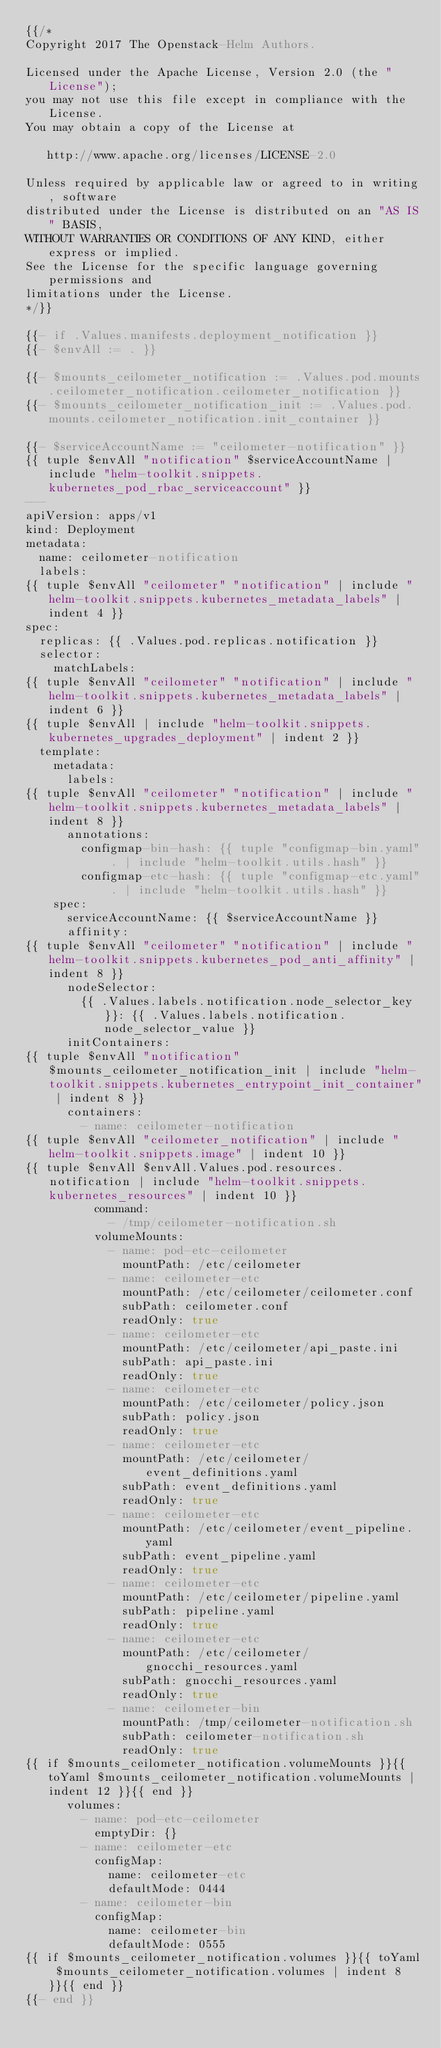<code> <loc_0><loc_0><loc_500><loc_500><_YAML_>{{/*
Copyright 2017 The Openstack-Helm Authors.

Licensed under the Apache License, Version 2.0 (the "License");
you may not use this file except in compliance with the License.
You may obtain a copy of the License at

   http://www.apache.org/licenses/LICENSE-2.0

Unless required by applicable law or agreed to in writing, software
distributed under the License is distributed on an "AS IS" BASIS,
WITHOUT WARRANTIES OR CONDITIONS OF ANY KIND, either express or implied.
See the License for the specific language governing permissions and
limitations under the License.
*/}}

{{- if .Values.manifests.deployment_notification }}
{{- $envAll := . }}

{{- $mounts_ceilometer_notification := .Values.pod.mounts.ceilometer_notification.ceilometer_notification }}
{{- $mounts_ceilometer_notification_init := .Values.pod.mounts.ceilometer_notification.init_container }}

{{- $serviceAccountName := "ceilometer-notification" }}
{{ tuple $envAll "notification" $serviceAccountName | include "helm-toolkit.snippets.kubernetes_pod_rbac_serviceaccount" }}
---
apiVersion: apps/v1
kind: Deployment
metadata:
  name: ceilometer-notification
  labels:
{{ tuple $envAll "ceilometer" "notification" | include "helm-toolkit.snippets.kubernetes_metadata_labels" | indent 4 }}
spec:
  replicas: {{ .Values.pod.replicas.notification }}
  selector:
    matchLabels:
{{ tuple $envAll "ceilometer" "notification" | include "helm-toolkit.snippets.kubernetes_metadata_labels" | indent 6 }}
{{ tuple $envAll | include "helm-toolkit.snippets.kubernetes_upgrades_deployment" | indent 2 }}
  template:
    metadata:
      labels:
{{ tuple $envAll "ceilometer" "notification" | include "helm-toolkit.snippets.kubernetes_metadata_labels" | indent 8 }}
      annotations:
        configmap-bin-hash: {{ tuple "configmap-bin.yaml" . | include "helm-toolkit.utils.hash" }}
        configmap-etc-hash: {{ tuple "configmap-etc.yaml" . | include "helm-toolkit.utils.hash" }}
    spec:
      serviceAccountName: {{ $serviceAccountName }}
      affinity:
{{ tuple $envAll "ceilometer" "notification" | include "helm-toolkit.snippets.kubernetes_pod_anti_affinity" | indent 8 }}
      nodeSelector:
        {{ .Values.labels.notification.node_selector_key }}: {{ .Values.labels.notification.node_selector_value }}
      initContainers:
{{ tuple $envAll "notification" $mounts_ceilometer_notification_init | include "helm-toolkit.snippets.kubernetes_entrypoint_init_container" | indent 8 }}
      containers:
        - name: ceilometer-notification
{{ tuple $envAll "ceilometer_notification" | include "helm-toolkit.snippets.image" | indent 10 }}
{{ tuple $envAll $envAll.Values.pod.resources.notification | include "helm-toolkit.snippets.kubernetes_resources" | indent 10 }}
          command:
            - /tmp/ceilometer-notification.sh
          volumeMounts:
            - name: pod-etc-ceilometer
              mountPath: /etc/ceilometer
            - name: ceilometer-etc
              mountPath: /etc/ceilometer/ceilometer.conf
              subPath: ceilometer.conf
              readOnly: true
            - name: ceilometer-etc
              mountPath: /etc/ceilometer/api_paste.ini
              subPath: api_paste.ini
              readOnly: true
            - name: ceilometer-etc
              mountPath: /etc/ceilometer/policy.json
              subPath: policy.json
              readOnly: true
            - name: ceilometer-etc
              mountPath: /etc/ceilometer/event_definitions.yaml
              subPath: event_definitions.yaml
              readOnly: true
            - name: ceilometer-etc
              mountPath: /etc/ceilometer/event_pipeline.yaml
              subPath: event_pipeline.yaml
              readOnly: true
            - name: ceilometer-etc
              mountPath: /etc/ceilometer/pipeline.yaml
              subPath: pipeline.yaml
              readOnly: true
            - name: ceilometer-etc
              mountPath: /etc/ceilometer/gnocchi_resources.yaml
              subPath: gnocchi_resources.yaml
              readOnly: true
            - name: ceilometer-bin
              mountPath: /tmp/ceilometer-notification.sh
              subPath: ceilometer-notification.sh
              readOnly: true
{{ if $mounts_ceilometer_notification.volumeMounts }}{{ toYaml $mounts_ceilometer_notification.volumeMounts | indent 12 }}{{ end }}
      volumes:
        - name: pod-etc-ceilometer
          emptyDir: {}
        - name: ceilometer-etc
          configMap:
            name: ceilometer-etc
            defaultMode: 0444
        - name: ceilometer-bin
          configMap:
            name: ceilometer-bin
            defaultMode: 0555
{{ if $mounts_ceilometer_notification.volumes }}{{ toYaml $mounts_ceilometer_notification.volumes | indent 8 }}{{ end }}
{{- end }}
</code> 